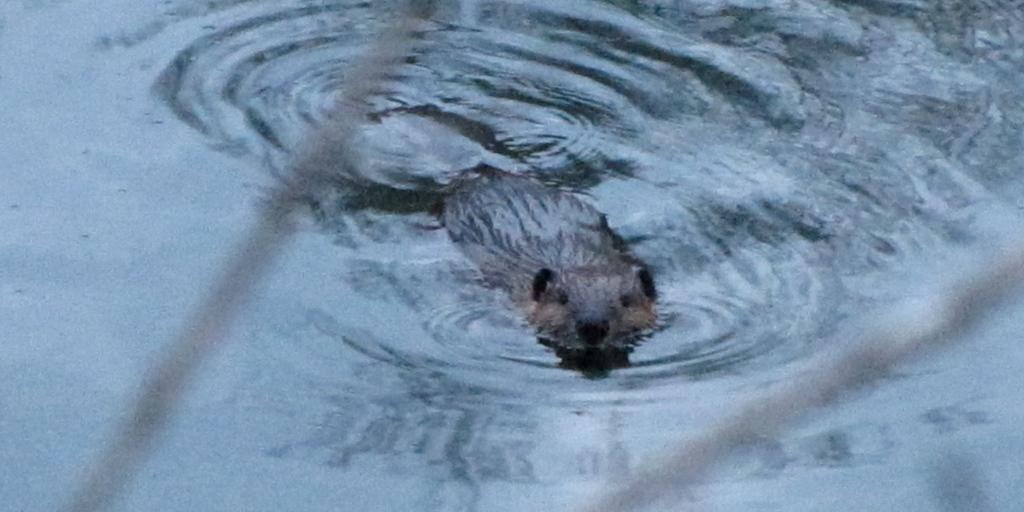What type of animal can be seen in the image? There is an animal in the water in the image. What type of observation is the doctor making with the cup in the image? There is no doctor or cup present in the image; it only features an animal in the water. 